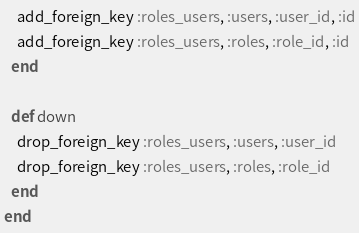<code> <loc_0><loc_0><loc_500><loc_500><_Crystal_>    add_foreign_key :roles_users, :users, :user_id, :id
    add_foreign_key :roles_users, :roles, :role_id, :id
  end

  def down
    drop_foreign_key :roles_users, :users, :user_id
    drop_foreign_key :roles_users, :roles, :role_id
  end
end
</code> 